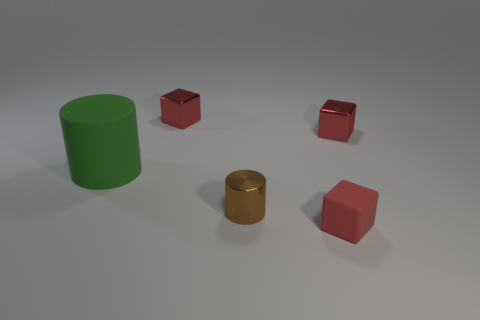How many objects are either cylinders or red blocks right of the big cylinder?
Give a very brief answer. 5. There is a red block that is in front of the large cylinder; is its size the same as the red metal block that is to the right of the tiny cylinder?
Provide a short and direct response. Yes. How many other rubber objects are the same shape as the brown thing?
Make the answer very short. 1. There is a tiny red object that is made of the same material as the big green cylinder; what shape is it?
Keep it short and to the point. Cube. What is the block that is behind the small metal thing that is right of the thing in front of the brown metallic cylinder made of?
Make the answer very short. Metal. There is a brown metallic cylinder; is it the same size as the block that is left of the red rubber thing?
Your answer should be compact. Yes. What material is the big green thing that is the same shape as the brown metal thing?
Your answer should be compact. Rubber. There is a green matte thing that is to the left of the red metal cube in front of the small red shiny cube that is left of the small red rubber thing; what is its size?
Keep it short and to the point. Large. Is the size of the matte cube the same as the green rubber cylinder?
Your answer should be compact. No. What material is the green thing that is on the left side of the small cube in front of the big thing?
Your answer should be compact. Rubber. 